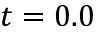<formula> <loc_0><loc_0><loc_500><loc_500>t = 0 . 0</formula> 